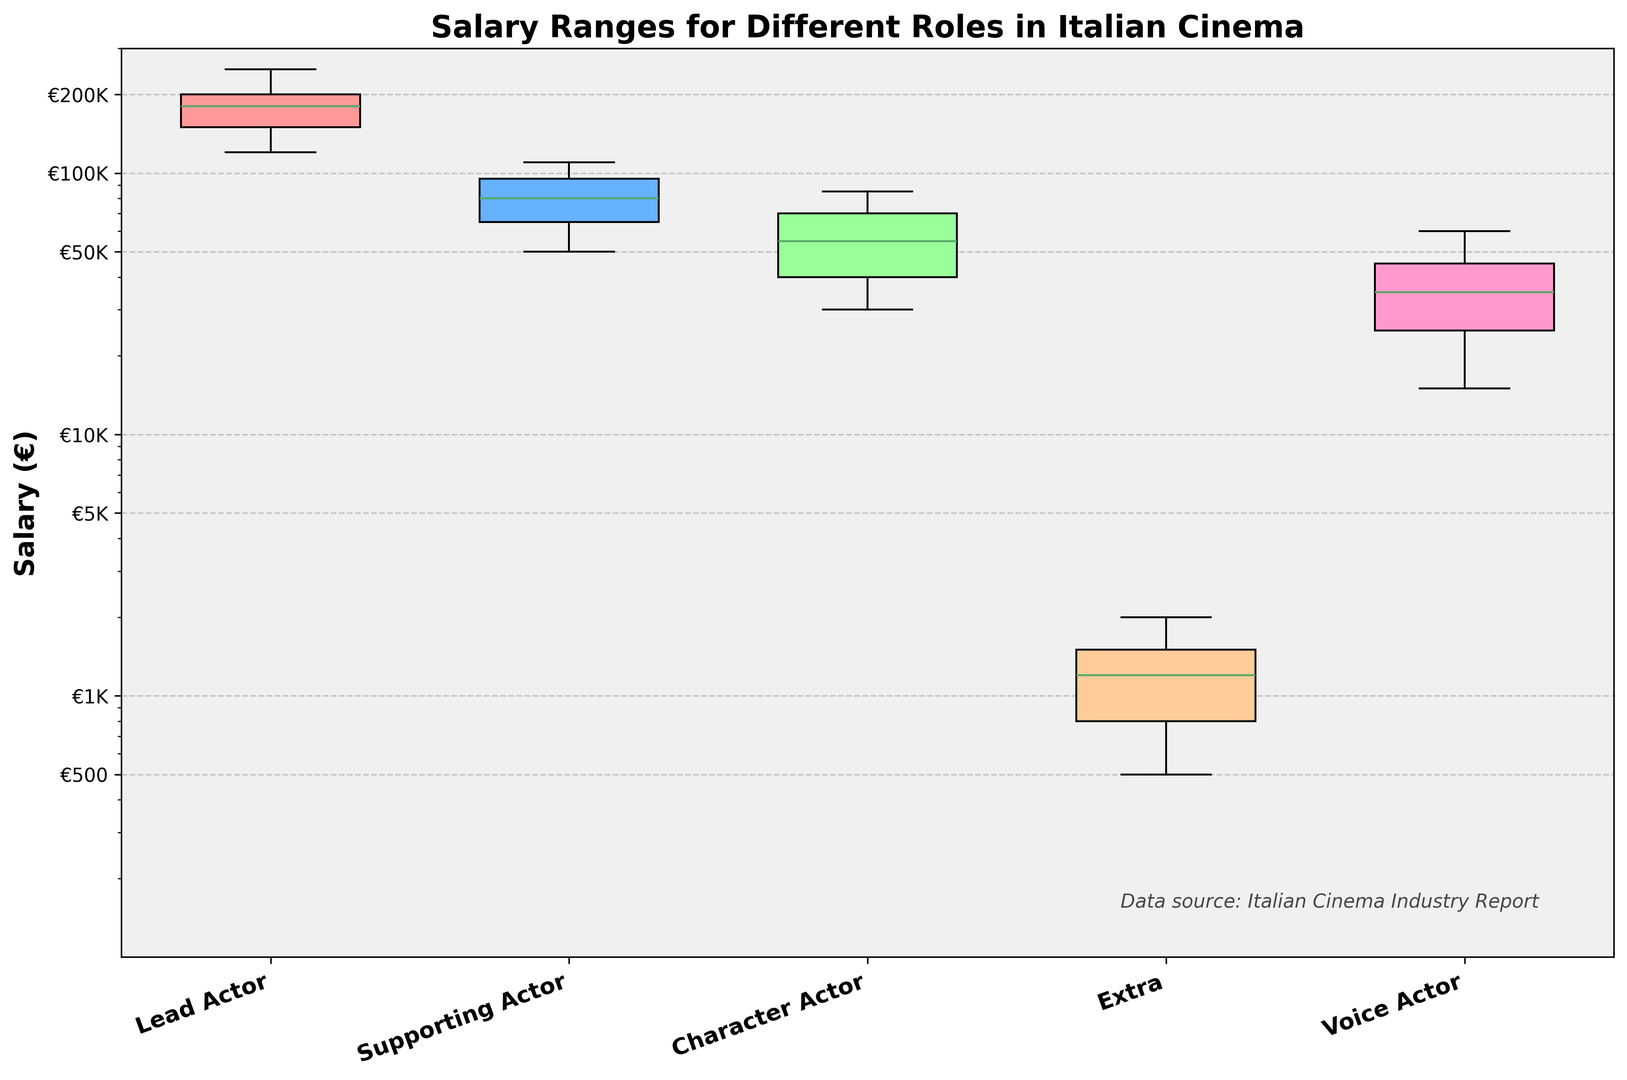What is the median salary of Lead Actors? The median salary is the middle value when data points are arranged in ascending order. For Lead Actors, the salaries are €120,000, €150,000, €180,000, €200,000, and €250,000. The median salary is the third value: €180,000.
Answer: €180,000 Which role has the highest median salary? To find the highest median salary, compare the median values of each role. Lead Actor has the highest median salary.
Answer: Lead Actor How does the salary range of Supporting Actors compare to that of Character Actors? Supporting Actors have salaries between €50,000 and €110,000, while Character Actors have salaries between €30,000 and €85,000. Supporting Actors generally have a higher salary range.
Answer: Supporting Actors generally earn more What is the interquartile range (IQR) of Voice Actors’ salaries? The IQR is the difference between the 75th percentile (upper quartile) and the 25th percentile (lower quartile). For Voice Actors, the salaries are €15,000, €25,000, €35,000, €45,000, and €60,000. The IQR is €45,000 - €25,000 = €20,000.
Answer: €20,000 Which role appears to have the greatest variability in salary? Variability can be seen through the length of the box and whiskers. Lead Actors show the greatest spread from around €120,000 to €250,000, indicating the greatest variability.
Answer: Lead Actor How does the maximum salary of Extras compare with the minimum salary of Character Actors? The maximum salary of Extras is €2,000, while the minimum salary of Character Actors is €30,000. The minimum salary of Character Actors is significantly higher.
Answer: Character Actors have higher minimum salaries What is the log-scaled range of salaries displayed in the plot? The y-axis shows a log scale from €100 to €300,000, covering several orders of magnitude.
Answer: €100 to €300,000 Which color represents the Lead Actor's box in the plot? According to the customization, the first box in the box plot uses the first color, which is red.
Answer: Red What is the upper whisker value for the Supporting Actor role? The upper whisker extends to the highest value within 1.5 times the interquartile range from the third quartile. For Supporting Actors, the highest non-outlier value is €110,000.
Answer: €110,000 Which role has the lowest minimum salary, and what is that value? Extras have the lowest minimum salary, which is €500.
Answer: Extras with €500 